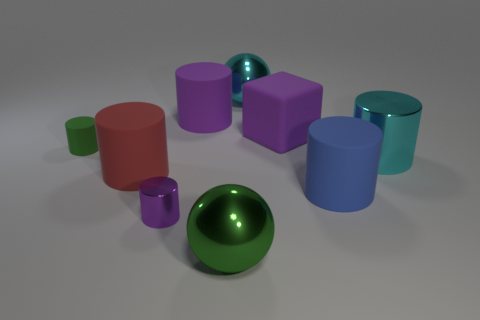Subtract all large metal cylinders. How many cylinders are left? 5 Subtract all cyan cylinders. How many cylinders are left? 5 Subtract 1 cylinders. How many cylinders are left? 5 Subtract all gray cylinders. Subtract all brown blocks. How many cylinders are left? 6 Add 1 purple rubber objects. How many objects exist? 10 Subtract all cylinders. How many objects are left? 3 Add 2 blocks. How many blocks are left? 3 Add 8 blue blocks. How many blue blocks exist? 8 Subtract 1 cyan cylinders. How many objects are left? 8 Subtract all green matte objects. Subtract all tiny purple cylinders. How many objects are left? 7 